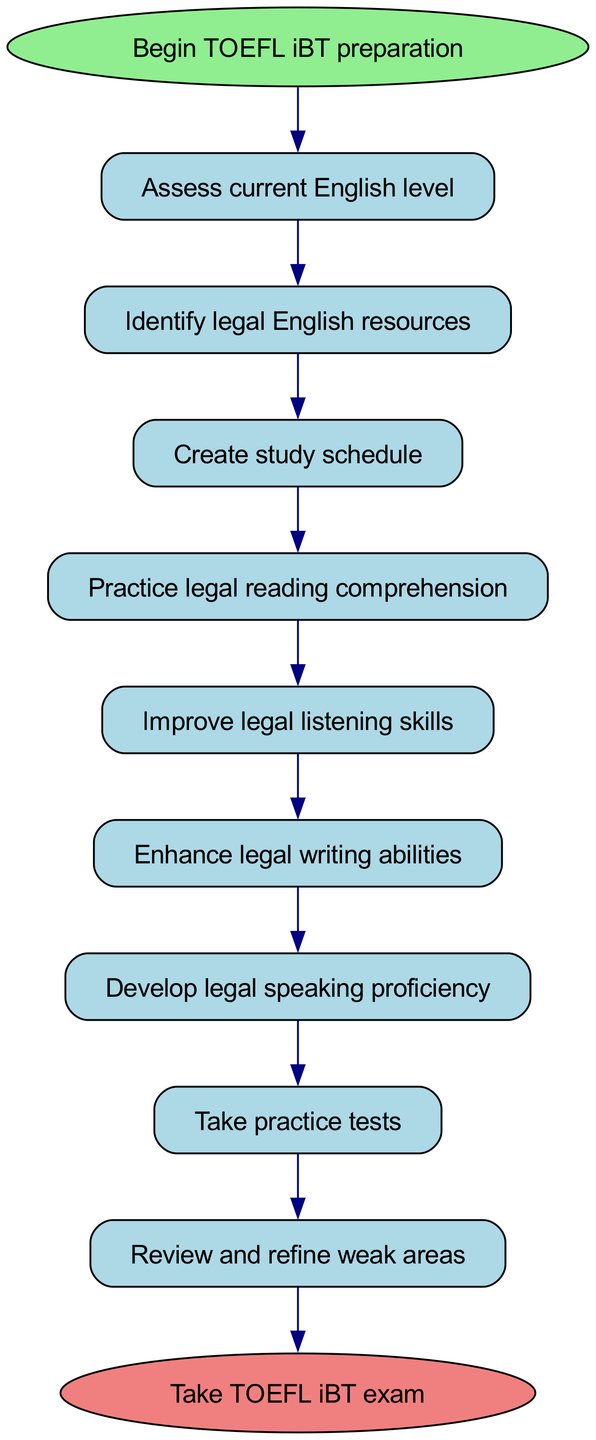What is the first step in preparing for the TOEFL iBT exam? The diagram shows "Assess current English level" as the first step, indicating it is the starting point in the preparation process.
Answer: Assess current English level How many steps are there in the TOEFL iBT preparation process? By counting the steps laid out in the diagram, we see that there are a total of nine steps before reaching the final action of taking the exam.
Answer: Nine What is the last action before taking the TOEFL iBT exam? The last node before the end node in the flow chart is "Register for TOEFL iBT exam," indicating it is the final action before the exam itself.
Answer: Register for TOEFL iBT exam Which two steps are connected directly by an edge in the flow chart? The steps "Practice legal reading comprehension" and "Improve legal listening skills" are connected directly by an edge, indicating a sequence in the preparation process.
Answer: Practice legal reading comprehension and Improve legal listening skills What step follows "Enhance legal writing abilities"? Referring to the flow of the diagram, the step that follows "Enhance legal writing abilities" is "Develop legal speaking proficiency," indicating the next area to focus on after improving writing skills.
Answer: Develop legal speaking proficiency If a student completes "Take practice tests," what is the next step? After completing the "Take practice tests" step, the diagram shows that the next action is to "Review and refine weak areas," which indicates a process of analyzing performance.
Answer: Review and refine weak areas How does the step "Improve legal listening skills" relate to "Enhance legal writing abilities"? The flow diagram shows that "Improve legal listening skills" leads directly to "Enhance legal writing abilities," indicating that improving listening skills is a prerequisite for enhancing writing skills.
Answer: Improve legal listening skills leads to Enhance legal writing abilities What resource do students identify after assessing their current English level? The diagram indicates that after assessing their current English level, students are to "Identify legal English resources," which helps in their preparation.
Answer: Identify legal English resources 